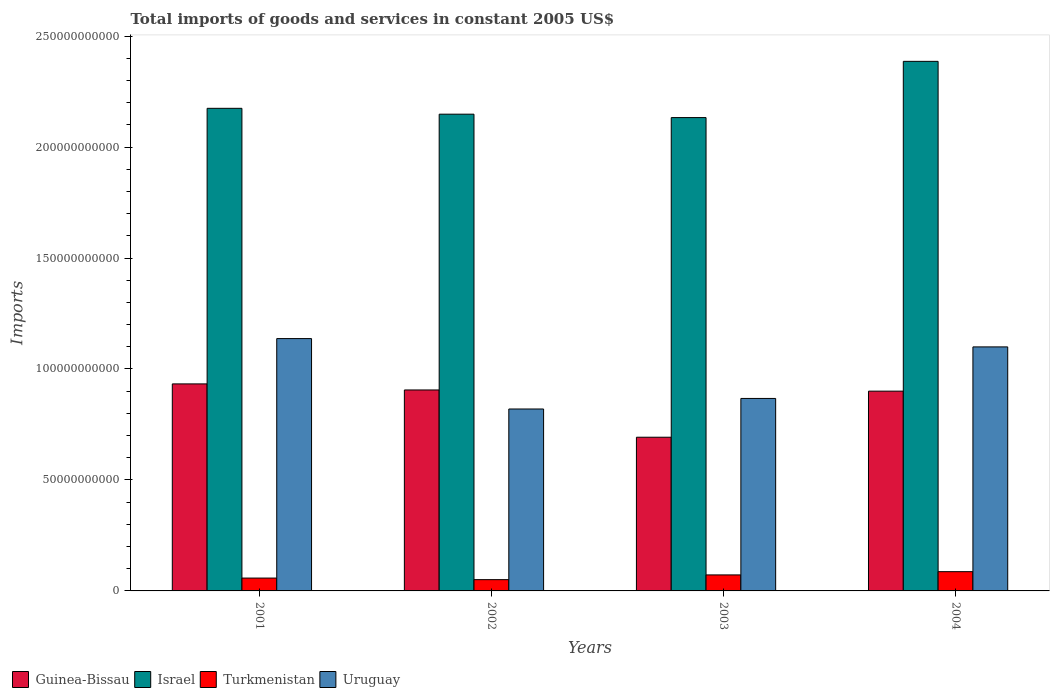Are the number of bars per tick equal to the number of legend labels?
Give a very brief answer. Yes. What is the label of the 1st group of bars from the left?
Your answer should be very brief. 2001. What is the total imports of goods and services in Israel in 2002?
Your answer should be very brief. 2.15e+11. Across all years, what is the maximum total imports of goods and services in Israel?
Offer a terse response. 2.39e+11. Across all years, what is the minimum total imports of goods and services in Israel?
Provide a short and direct response. 2.13e+11. What is the total total imports of goods and services in Turkmenistan in the graph?
Keep it short and to the point. 2.68e+1. What is the difference between the total imports of goods and services in Israel in 2001 and that in 2004?
Offer a very short reply. -2.12e+1. What is the difference between the total imports of goods and services in Turkmenistan in 2003 and the total imports of goods and services in Israel in 2001?
Keep it short and to the point. -2.10e+11. What is the average total imports of goods and services in Israel per year?
Provide a short and direct response. 2.21e+11. In the year 2004, what is the difference between the total imports of goods and services in Uruguay and total imports of goods and services in Turkmenistan?
Ensure brevity in your answer.  1.01e+11. What is the ratio of the total imports of goods and services in Guinea-Bissau in 2002 to that in 2004?
Make the answer very short. 1.01. Is the difference between the total imports of goods and services in Uruguay in 2001 and 2003 greater than the difference between the total imports of goods and services in Turkmenistan in 2001 and 2003?
Your response must be concise. Yes. What is the difference between the highest and the second highest total imports of goods and services in Uruguay?
Provide a short and direct response. 3.75e+09. What is the difference between the highest and the lowest total imports of goods and services in Israel?
Provide a short and direct response. 2.53e+1. Is it the case that in every year, the sum of the total imports of goods and services in Uruguay and total imports of goods and services in Israel is greater than the sum of total imports of goods and services in Guinea-Bissau and total imports of goods and services in Turkmenistan?
Your answer should be very brief. Yes. What does the 3rd bar from the left in 2001 represents?
Keep it short and to the point. Turkmenistan. What does the 1st bar from the right in 2004 represents?
Ensure brevity in your answer.  Uruguay. How many bars are there?
Offer a very short reply. 16. Are all the bars in the graph horizontal?
Make the answer very short. No. What is the difference between two consecutive major ticks on the Y-axis?
Offer a very short reply. 5.00e+1. Are the values on the major ticks of Y-axis written in scientific E-notation?
Ensure brevity in your answer.  No. Does the graph contain any zero values?
Ensure brevity in your answer.  No. Does the graph contain grids?
Make the answer very short. No. How are the legend labels stacked?
Make the answer very short. Horizontal. What is the title of the graph?
Make the answer very short. Total imports of goods and services in constant 2005 US$. Does "Low & middle income" appear as one of the legend labels in the graph?
Offer a very short reply. No. What is the label or title of the Y-axis?
Provide a short and direct response. Imports. What is the Imports of Guinea-Bissau in 2001?
Offer a very short reply. 9.33e+1. What is the Imports of Israel in 2001?
Ensure brevity in your answer.  2.17e+11. What is the Imports in Turkmenistan in 2001?
Give a very brief answer. 5.79e+09. What is the Imports of Uruguay in 2001?
Provide a short and direct response. 1.14e+11. What is the Imports in Guinea-Bissau in 2002?
Offer a very short reply. 9.06e+1. What is the Imports of Israel in 2002?
Make the answer very short. 2.15e+11. What is the Imports of Turkmenistan in 2002?
Offer a terse response. 5.08e+09. What is the Imports in Uruguay in 2002?
Your response must be concise. 8.20e+1. What is the Imports of Guinea-Bissau in 2003?
Ensure brevity in your answer.  6.93e+1. What is the Imports in Israel in 2003?
Offer a terse response. 2.13e+11. What is the Imports in Turkmenistan in 2003?
Ensure brevity in your answer.  7.21e+09. What is the Imports of Uruguay in 2003?
Provide a short and direct response. 8.67e+1. What is the Imports of Guinea-Bissau in 2004?
Provide a short and direct response. 9.00e+1. What is the Imports in Israel in 2004?
Make the answer very short. 2.39e+11. What is the Imports of Turkmenistan in 2004?
Your answer should be compact. 8.68e+09. What is the Imports in Uruguay in 2004?
Offer a very short reply. 1.10e+11. Across all years, what is the maximum Imports in Guinea-Bissau?
Provide a short and direct response. 9.33e+1. Across all years, what is the maximum Imports in Israel?
Your response must be concise. 2.39e+11. Across all years, what is the maximum Imports in Turkmenistan?
Offer a very short reply. 8.68e+09. Across all years, what is the maximum Imports of Uruguay?
Your answer should be compact. 1.14e+11. Across all years, what is the minimum Imports of Guinea-Bissau?
Provide a short and direct response. 6.93e+1. Across all years, what is the minimum Imports of Israel?
Provide a short and direct response. 2.13e+11. Across all years, what is the minimum Imports of Turkmenistan?
Provide a short and direct response. 5.08e+09. Across all years, what is the minimum Imports of Uruguay?
Offer a very short reply. 8.20e+1. What is the total Imports in Guinea-Bissau in the graph?
Offer a terse response. 3.43e+11. What is the total Imports in Israel in the graph?
Give a very brief answer. 8.84e+11. What is the total Imports in Turkmenistan in the graph?
Ensure brevity in your answer.  2.68e+1. What is the total Imports in Uruguay in the graph?
Your answer should be very brief. 3.92e+11. What is the difference between the Imports of Guinea-Bissau in 2001 and that in 2002?
Make the answer very short. 2.73e+09. What is the difference between the Imports of Israel in 2001 and that in 2002?
Offer a terse response. 2.64e+09. What is the difference between the Imports in Turkmenistan in 2001 and that in 2002?
Ensure brevity in your answer.  7.12e+08. What is the difference between the Imports of Uruguay in 2001 and that in 2002?
Your answer should be compact. 3.17e+1. What is the difference between the Imports of Guinea-Bissau in 2001 and that in 2003?
Make the answer very short. 2.40e+1. What is the difference between the Imports of Israel in 2001 and that in 2003?
Make the answer very short. 4.18e+09. What is the difference between the Imports in Turkmenistan in 2001 and that in 2003?
Make the answer very short. -1.42e+09. What is the difference between the Imports in Uruguay in 2001 and that in 2003?
Give a very brief answer. 2.70e+1. What is the difference between the Imports in Guinea-Bissau in 2001 and that in 2004?
Your answer should be very brief. 3.27e+09. What is the difference between the Imports of Israel in 2001 and that in 2004?
Make the answer very short. -2.12e+1. What is the difference between the Imports of Turkmenistan in 2001 and that in 2004?
Your answer should be very brief. -2.89e+09. What is the difference between the Imports of Uruguay in 2001 and that in 2004?
Your answer should be compact. 3.75e+09. What is the difference between the Imports of Guinea-Bissau in 2002 and that in 2003?
Your response must be concise. 2.13e+1. What is the difference between the Imports of Israel in 2002 and that in 2003?
Ensure brevity in your answer.  1.53e+09. What is the difference between the Imports of Turkmenistan in 2002 and that in 2003?
Keep it short and to the point. -2.13e+09. What is the difference between the Imports of Uruguay in 2002 and that in 2003?
Make the answer very short. -4.76e+09. What is the difference between the Imports of Guinea-Bissau in 2002 and that in 2004?
Your answer should be very brief. 5.35e+08. What is the difference between the Imports of Israel in 2002 and that in 2004?
Make the answer very short. -2.38e+1. What is the difference between the Imports of Turkmenistan in 2002 and that in 2004?
Your answer should be very brief. -3.60e+09. What is the difference between the Imports of Uruguay in 2002 and that in 2004?
Your response must be concise. -2.80e+1. What is the difference between the Imports of Guinea-Bissau in 2003 and that in 2004?
Provide a short and direct response. -2.08e+1. What is the difference between the Imports of Israel in 2003 and that in 2004?
Offer a very short reply. -2.53e+1. What is the difference between the Imports in Turkmenistan in 2003 and that in 2004?
Give a very brief answer. -1.46e+09. What is the difference between the Imports in Uruguay in 2003 and that in 2004?
Make the answer very short. -2.32e+1. What is the difference between the Imports in Guinea-Bissau in 2001 and the Imports in Israel in 2002?
Keep it short and to the point. -1.22e+11. What is the difference between the Imports of Guinea-Bissau in 2001 and the Imports of Turkmenistan in 2002?
Offer a terse response. 8.82e+1. What is the difference between the Imports in Guinea-Bissau in 2001 and the Imports in Uruguay in 2002?
Your answer should be very brief. 1.13e+1. What is the difference between the Imports of Israel in 2001 and the Imports of Turkmenistan in 2002?
Ensure brevity in your answer.  2.12e+11. What is the difference between the Imports of Israel in 2001 and the Imports of Uruguay in 2002?
Offer a very short reply. 1.35e+11. What is the difference between the Imports in Turkmenistan in 2001 and the Imports in Uruguay in 2002?
Ensure brevity in your answer.  -7.62e+1. What is the difference between the Imports of Guinea-Bissau in 2001 and the Imports of Israel in 2003?
Your answer should be compact. -1.20e+11. What is the difference between the Imports in Guinea-Bissau in 2001 and the Imports in Turkmenistan in 2003?
Offer a terse response. 8.61e+1. What is the difference between the Imports of Guinea-Bissau in 2001 and the Imports of Uruguay in 2003?
Give a very brief answer. 6.55e+09. What is the difference between the Imports in Israel in 2001 and the Imports in Turkmenistan in 2003?
Give a very brief answer. 2.10e+11. What is the difference between the Imports of Israel in 2001 and the Imports of Uruguay in 2003?
Make the answer very short. 1.31e+11. What is the difference between the Imports in Turkmenistan in 2001 and the Imports in Uruguay in 2003?
Your answer should be very brief. -8.09e+1. What is the difference between the Imports in Guinea-Bissau in 2001 and the Imports in Israel in 2004?
Ensure brevity in your answer.  -1.45e+11. What is the difference between the Imports of Guinea-Bissau in 2001 and the Imports of Turkmenistan in 2004?
Your response must be concise. 8.46e+1. What is the difference between the Imports in Guinea-Bissau in 2001 and the Imports in Uruguay in 2004?
Your response must be concise. -1.67e+1. What is the difference between the Imports of Israel in 2001 and the Imports of Turkmenistan in 2004?
Ensure brevity in your answer.  2.09e+11. What is the difference between the Imports in Israel in 2001 and the Imports in Uruguay in 2004?
Provide a succinct answer. 1.08e+11. What is the difference between the Imports of Turkmenistan in 2001 and the Imports of Uruguay in 2004?
Provide a succinct answer. -1.04e+11. What is the difference between the Imports in Guinea-Bissau in 2002 and the Imports in Israel in 2003?
Keep it short and to the point. -1.23e+11. What is the difference between the Imports in Guinea-Bissau in 2002 and the Imports in Turkmenistan in 2003?
Give a very brief answer. 8.33e+1. What is the difference between the Imports of Guinea-Bissau in 2002 and the Imports of Uruguay in 2003?
Provide a succinct answer. 3.82e+09. What is the difference between the Imports in Israel in 2002 and the Imports in Turkmenistan in 2003?
Make the answer very short. 2.08e+11. What is the difference between the Imports in Israel in 2002 and the Imports in Uruguay in 2003?
Provide a short and direct response. 1.28e+11. What is the difference between the Imports of Turkmenistan in 2002 and the Imports of Uruguay in 2003?
Your answer should be very brief. -8.16e+1. What is the difference between the Imports of Guinea-Bissau in 2002 and the Imports of Israel in 2004?
Provide a short and direct response. -1.48e+11. What is the difference between the Imports of Guinea-Bissau in 2002 and the Imports of Turkmenistan in 2004?
Offer a terse response. 8.19e+1. What is the difference between the Imports in Guinea-Bissau in 2002 and the Imports in Uruguay in 2004?
Keep it short and to the point. -1.94e+1. What is the difference between the Imports of Israel in 2002 and the Imports of Turkmenistan in 2004?
Your answer should be compact. 2.06e+11. What is the difference between the Imports of Israel in 2002 and the Imports of Uruguay in 2004?
Ensure brevity in your answer.  1.05e+11. What is the difference between the Imports of Turkmenistan in 2002 and the Imports of Uruguay in 2004?
Your answer should be very brief. -1.05e+11. What is the difference between the Imports of Guinea-Bissau in 2003 and the Imports of Israel in 2004?
Offer a terse response. -1.69e+11. What is the difference between the Imports of Guinea-Bissau in 2003 and the Imports of Turkmenistan in 2004?
Offer a terse response. 6.06e+1. What is the difference between the Imports in Guinea-Bissau in 2003 and the Imports in Uruguay in 2004?
Give a very brief answer. -4.07e+1. What is the difference between the Imports in Israel in 2003 and the Imports in Turkmenistan in 2004?
Your answer should be compact. 2.05e+11. What is the difference between the Imports of Israel in 2003 and the Imports of Uruguay in 2004?
Give a very brief answer. 1.03e+11. What is the difference between the Imports of Turkmenistan in 2003 and the Imports of Uruguay in 2004?
Your answer should be compact. -1.03e+11. What is the average Imports of Guinea-Bissau per year?
Offer a very short reply. 8.58e+1. What is the average Imports of Israel per year?
Give a very brief answer. 2.21e+11. What is the average Imports in Turkmenistan per year?
Provide a succinct answer. 6.69e+09. What is the average Imports in Uruguay per year?
Make the answer very short. 9.81e+1. In the year 2001, what is the difference between the Imports of Guinea-Bissau and Imports of Israel?
Keep it short and to the point. -1.24e+11. In the year 2001, what is the difference between the Imports of Guinea-Bissau and Imports of Turkmenistan?
Give a very brief answer. 8.75e+1. In the year 2001, what is the difference between the Imports of Guinea-Bissau and Imports of Uruguay?
Keep it short and to the point. -2.04e+1. In the year 2001, what is the difference between the Imports in Israel and Imports in Turkmenistan?
Your answer should be compact. 2.12e+11. In the year 2001, what is the difference between the Imports in Israel and Imports in Uruguay?
Your answer should be very brief. 1.04e+11. In the year 2001, what is the difference between the Imports of Turkmenistan and Imports of Uruguay?
Your response must be concise. -1.08e+11. In the year 2002, what is the difference between the Imports in Guinea-Bissau and Imports in Israel?
Ensure brevity in your answer.  -1.24e+11. In the year 2002, what is the difference between the Imports of Guinea-Bissau and Imports of Turkmenistan?
Give a very brief answer. 8.55e+1. In the year 2002, what is the difference between the Imports in Guinea-Bissau and Imports in Uruguay?
Ensure brevity in your answer.  8.58e+09. In the year 2002, what is the difference between the Imports of Israel and Imports of Turkmenistan?
Give a very brief answer. 2.10e+11. In the year 2002, what is the difference between the Imports of Israel and Imports of Uruguay?
Make the answer very short. 1.33e+11. In the year 2002, what is the difference between the Imports in Turkmenistan and Imports in Uruguay?
Provide a short and direct response. -7.69e+1. In the year 2003, what is the difference between the Imports of Guinea-Bissau and Imports of Israel?
Provide a succinct answer. -1.44e+11. In the year 2003, what is the difference between the Imports in Guinea-Bissau and Imports in Turkmenistan?
Your answer should be compact. 6.20e+1. In the year 2003, what is the difference between the Imports of Guinea-Bissau and Imports of Uruguay?
Ensure brevity in your answer.  -1.75e+1. In the year 2003, what is the difference between the Imports of Israel and Imports of Turkmenistan?
Offer a terse response. 2.06e+11. In the year 2003, what is the difference between the Imports of Israel and Imports of Uruguay?
Your answer should be very brief. 1.27e+11. In the year 2003, what is the difference between the Imports in Turkmenistan and Imports in Uruguay?
Offer a terse response. -7.95e+1. In the year 2004, what is the difference between the Imports of Guinea-Bissau and Imports of Israel?
Ensure brevity in your answer.  -1.49e+11. In the year 2004, what is the difference between the Imports of Guinea-Bissau and Imports of Turkmenistan?
Your answer should be very brief. 8.13e+1. In the year 2004, what is the difference between the Imports of Guinea-Bissau and Imports of Uruguay?
Keep it short and to the point. -1.99e+1. In the year 2004, what is the difference between the Imports of Israel and Imports of Turkmenistan?
Offer a very short reply. 2.30e+11. In the year 2004, what is the difference between the Imports in Israel and Imports in Uruguay?
Your response must be concise. 1.29e+11. In the year 2004, what is the difference between the Imports in Turkmenistan and Imports in Uruguay?
Keep it short and to the point. -1.01e+11. What is the ratio of the Imports in Guinea-Bissau in 2001 to that in 2002?
Your answer should be compact. 1.03. What is the ratio of the Imports of Israel in 2001 to that in 2002?
Offer a very short reply. 1.01. What is the ratio of the Imports of Turkmenistan in 2001 to that in 2002?
Give a very brief answer. 1.14. What is the ratio of the Imports in Uruguay in 2001 to that in 2002?
Offer a very short reply. 1.39. What is the ratio of the Imports in Guinea-Bissau in 2001 to that in 2003?
Offer a terse response. 1.35. What is the ratio of the Imports of Israel in 2001 to that in 2003?
Make the answer very short. 1.02. What is the ratio of the Imports of Turkmenistan in 2001 to that in 2003?
Ensure brevity in your answer.  0.8. What is the ratio of the Imports of Uruguay in 2001 to that in 2003?
Provide a short and direct response. 1.31. What is the ratio of the Imports in Guinea-Bissau in 2001 to that in 2004?
Keep it short and to the point. 1.04. What is the ratio of the Imports in Israel in 2001 to that in 2004?
Make the answer very short. 0.91. What is the ratio of the Imports of Turkmenistan in 2001 to that in 2004?
Make the answer very short. 0.67. What is the ratio of the Imports in Uruguay in 2001 to that in 2004?
Offer a terse response. 1.03. What is the ratio of the Imports of Guinea-Bissau in 2002 to that in 2003?
Provide a short and direct response. 1.31. What is the ratio of the Imports in Israel in 2002 to that in 2003?
Offer a very short reply. 1.01. What is the ratio of the Imports of Turkmenistan in 2002 to that in 2003?
Offer a terse response. 0.7. What is the ratio of the Imports in Uruguay in 2002 to that in 2003?
Your answer should be very brief. 0.95. What is the ratio of the Imports of Guinea-Bissau in 2002 to that in 2004?
Provide a succinct answer. 1.01. What is the ratio of the Imports of Israel in 2002 to that in 2004?
Offer a terse response. 0.9. What is the ratio of the Imports of Turkmenistan in 2002 to that in 2004?
Provide a succinct answer. 0.59. What is the ratio of the Imports of Uruguay in 2002 to that in 2004?
Offer a very short reply. 0.75. What is the ratio of the Imports of Guinea-Bissau in 2003 to that in 2004?
Give a very brief answer. 0.77. What is the ratio of the Imports of Israel in 2003 to that in 2004?
Ensure brevity in your answer.  0.89. What is the ratio of the Imports of Turkmenistan in 2003 to that in 2004?
Ensure brevity in your answer.  0.83. What is the ratio of the Imports of Uruguay in 2003 to that in 2004?
Give a very brief answer. 0.79. What is the difference between the highest and the second highest Imports in Guinea-Bissau?
Offer a terse response. 2.73e+09. What is the difference between the highest and the second highest Imports of Israel?
Your answer should be compact. 2.12e+1. What is the difference between the highest and the second highest Imports in Turkmenistan?
Your response must be concise. 1.46e+09. What is the difference between the highest and the second highest Imports of Uruguay?
Provide a short and direct response. 3.75e+09. What is the difference between the highest and the lowest Imports in Guinea-Bissau?
Your response must be concise. 2.40e+1. What is the difference between the highest and the lowest Imports in Israel?
Ensure brevity in your answer.  2.53e+1. What is the difference between the highest and the lowest Imports of Turkmenistan?
Keep it short and to the point. 3.60e+09. What is the difference between the highest and the lowest Imports of Uruguay?
Give a very brief answer. 3.17e+1. 